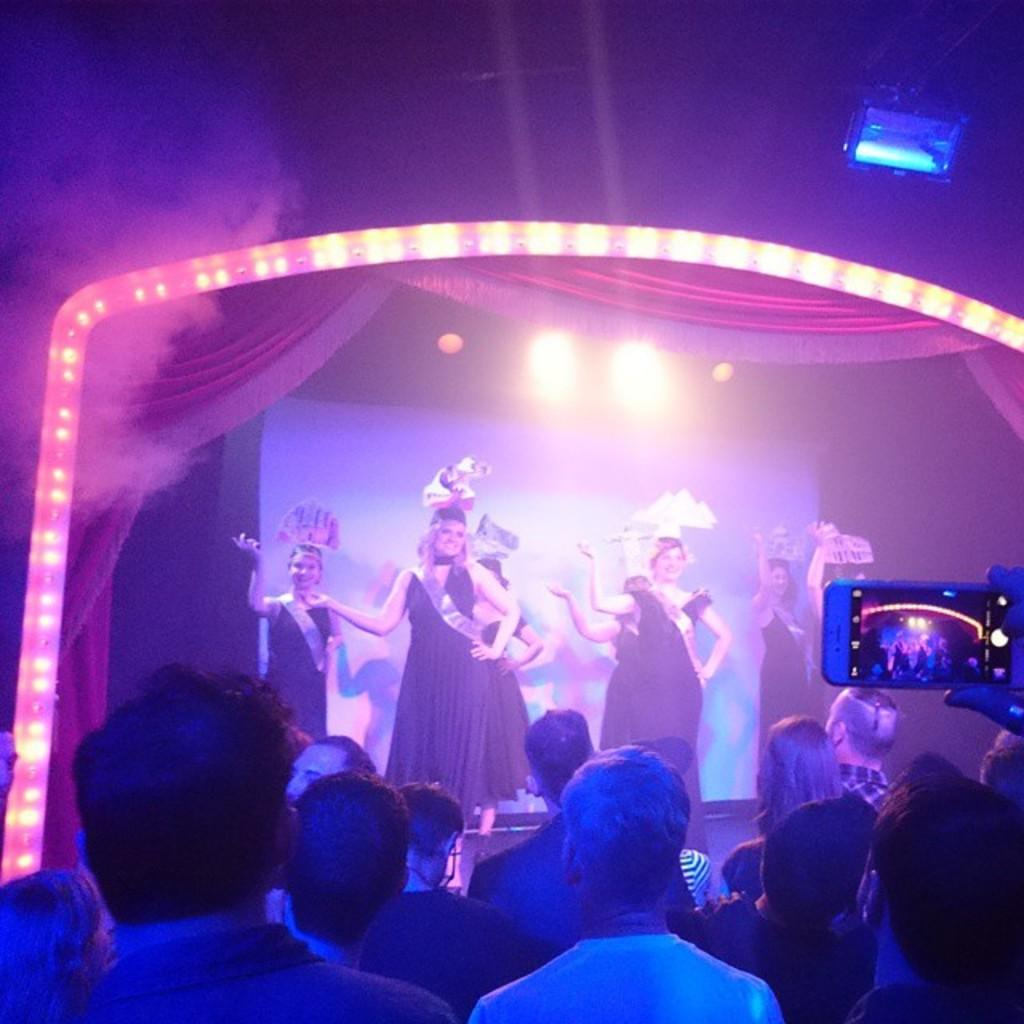What is happening on the stage in the image? There are people on the stage in the image. What is happening in front of the stage? There are people in front of the stage in the image. Can you describe the actions of one person in front of the stage? One person in front of the stage is holding a phone. What can be seen in the image that might be related to the lighting? There are lights visible in the image, and there is lighting present in the image. What type of iron is being used for trade in the image? There is no iron or trade present in the image; it features people on and in front of a stage with lights and a person holding a phone. 